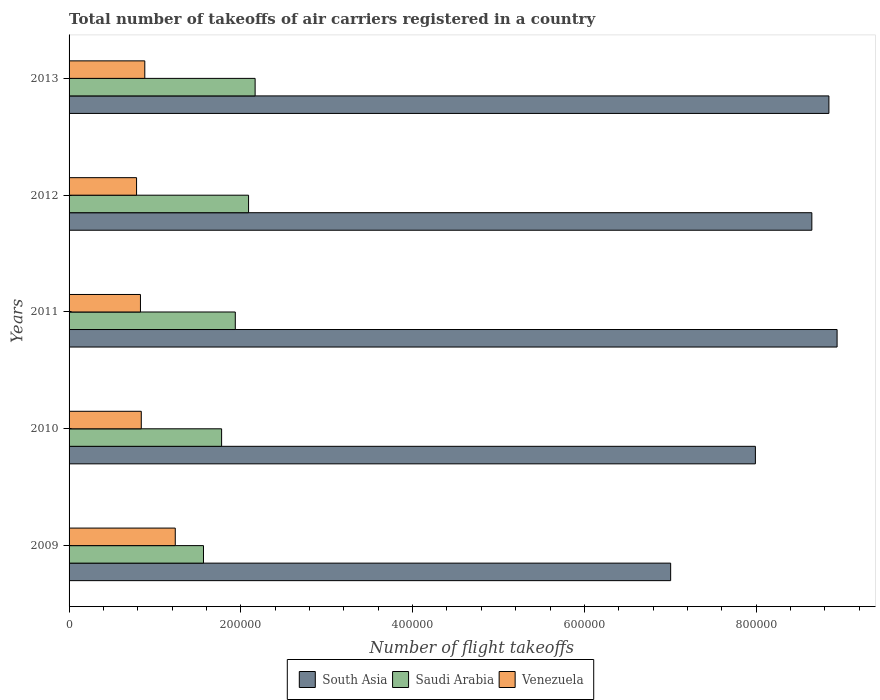How many groups of bars are there?
Your answer should be very brief. 5. How many bars are there on the 2nd tick from the bottom?
Keep it short and to the point. 3. What is the label of the 1st group of bars from the top?
Offer a very short reply. 2013. In how many cases, is the number of bars for a given year not equal to the number of legend labels?
Make the answer very short. 0. What is the total number of flight takeoffs in Venezuela in 2010?
Keep it short and to the point. 8.41e+04. Across all years, what is the maximum total number of flight takeoffs in Venezuela?
Your answer should be very brief. 1.24e+05. Across all years, what is the minimum total number of flight takeoffs in Saudi Arabia?
Provide a short and direct response. 1.56e+05. In which year was the total number of flight takeoffs in Venezuela minimum?
Offer a terse response. 2012. What is the total total number of flight takeoffs in Venezuela in the graph?
Make the answer very short. 4.58e+05. What is the difference between the total number of flight takeoffs in Saudi Arabia in 2009 and that in 2013?
Your answer should be compact. -6.01e+04. What is the difference between the total number of flight takeoffs in Venezuela in 2009 and the total number of flight takeoffs in South Asia in 2011?
Your response must be concise. -7.71e+05. What is the average total number of flight takeoffs in South Asia per year?
Give a very brief answer. 8.29e+05. In the year 2012, what is the difference between the total number of flight takeoffs in South Asia and total number of flight takeoffs in Venezuela?
Give a very brief answer. 7.86e+05. What is the ratio of the total number of flight takeoffs in South Asia in 2012 to that in 2013?
Your response must be concise. 0.98. Is the total number of flight takeoffs in South Asia in 2009 less than that in 2013?
Offer a very short reply. Yes. Is the difference between the total number of flight takeoffs in South Asia in 2010 and 2012 greater than the difference between the total number of flight takeoffs in Venezuela in 2010 and 2012?
Give a very brief answer. No. What is the difference between the highest and the second highest total number of flight takeoffs in Saudi Arabia?
Your answer should be very brief. 7630. What is the difference between the highest and the lowest total number of flight takeoffs in South Asia?
Your answer should be very brief. 1.94e+05. What does the 1st bar from the bottom in 2013 represents?
Provide a succinct answer. South Asia. Does the graph contain grids?
Offer a very short reply. No. What is the title of the graph?
Give a very brief answer. Total number of takeoffs of air carriers registered in a country. What is the label or title of the X-axis?
Offer a very short reply. Number of flight takeoffs. What is the label or title of the Y-axis?
Ensure brevity in your answer.  Years. What is the Number of flight takeoffs in South Asia in 2009?
Ensure brevity in your answer.  7.00e+05. What is the Number of flight takeoffs in Saudi Arabia in 2009?
Provide a succinct answer. 1.56e+05. What is the Number of flight takeoffs of Venezuela in 2009?
Offer a very short reply. 1.24e+05. What is the Number of flight takeoffs of South Asia in 2010?
Ensure brevity in your answer.  7.99e+05. What is the Number of flight takeoffs in Saudi Arabia in 2010?
Offer a very short reply. 1.78e+05. What is the Number of flight takeoffs in Venezuela in 2010?
Give a very brief answer. 8.41e+04. What is the Number of flight takeoffs of South Asia in 2011?
Make the answer very short. 8.94e+05. What is the Number of flight takeoffs in Saudi Arabia in 2011?
Provide a short and direct response. 1.94e+05. What is the Number of flight takeoffs of Venezuela in 2011?
Offer a very short reply. 8.31e+04. What is the Number of flight takeoffs in South Asia in 2012?
Keep it short and to the point. 8.65e+05. What is the Number of flight takeoffs in Saudi Arabia in 2012?
Your answer should be compact. 2.09e+05. What is the Number of flight takeoffs of Venezuela in 2012?
Your response must be concise. 7.86e+04. What is the Number of flight takeoffs of South Asia in 2013?
Your answer should be very brief. 8.85e+05. What is the Number of flight takeoffs in Saudi Arabia in 2013?
Make the answer very short. 2.17e+05. What is the Number of flight takeoffs in Venezuela in 2013?
Provide a short and direct response. 8.82e+04. Across all years, what is the maximum Number of flight takeoffs in South Asia?
Your answer should be compact. 8.94e+05. Across all years, what is the maximum Number of flight takeoffs in Saudi Arabia?
Offer a terse response. 2.17e+05. Across all years, what is the maximum Number of flight takeoffs in Venezuela?
Make the answer very short. 1.24e+05. Across all years, what is the minimum Number of flight takeoffs in South Asia?
Your response must be concise. 7.00e+05. Across all years, what is the minimum Number of flight takeoffs in Saudi Arabia?
Give a very brief answer. 1.56e+05. Across all years, what is the minimum Number of flight takeoffs in Venezuela?
Offer a terse response. 7.86e+04. What is the total Number of flight takeoffs of South Asia in the graph?
Provide a succinct answer. 4.14e+06. What is the total Number of flight takeoffs of Saudi Arabia in the graph?
Your answer should be very brief. 9.53e+05. What is the total Number of flight takeoffs of Venezuela in the graph?
Provide a succinct answer. 4.58e+05. What is the difference between the Number of flight takeoffs in South Asia in 2009 and that in 2010?
Your answer should be very brief. -9.86e+04. What is the difference between the Number of flight takeoffs of Saudi Arabia in 2009 and that in 2010?
Offer a terse response. -2.11e+04. What is the difference between the Number of flight takeoffs in Venezuela in 2009 and that in 2010?
Keep it short and to the point. 3.96e+04. What is the difference between the Number of flight takeoffs of South Asia in 2009 and that in 2011?
Keep it short and to the point. -1.94e+05. What is the difference between the Number of flight takeoffs of Saudi Arabia in 2009 and that in 2011?
Offer a terse response. -3.70e+04. What is the difference between the Number of flight takeoffs in Venezuela in 2009 and that in 2011?
Provide a succinct answer. 4.05e+04. What is the difference between the Number of flight takeoffs in South Asia in 2009 and that in 2012?
Give a very brief answer. -1.64e+05. What is the difference between the Number of flight takeoffs in Saudi Arabia in 2009 and that in 2012?
Offer a terse response. -5.25e+04. What is the difference between the Number of flight takeoffs in Venezuela in 2009 and that in 2012?
Your answer should be very brief. 4.51e+04. What is the difference between the Number of flight takeoffs in South Asia in 2009 and that in 2013?
Your answer should be very brief. -1.84e+05. What is the difference between the Number of flight takeoffs of Saudi Arabia in 2009 and that in 2013?
Offer a very short reply. -6.01e+04. What is the difference between the Number of flight takeoffs of Venezuela in 2009 and that in 2013?
Your answer should be very brief. 3.55e+04. What is the difference between the Number of flight takeoffs in South Asia in 2010 and that in 2011?
Your answer should be compact. -9.51e+04. What is the difference between the Number of flight takeoffs of Saudi Arabia in 2010 and that in 2011?
Provide a short and direct response. -1.59e+04. What is the difference between the Number of flight takeoffs in Venezuela in 2010 and that in 2011?
Your answer should be very brief. 959. What is the difference between the Number of flight takeoffs in South Asia in 2010 and that in 2012?
Your answer should be very brief. -6.57e+04. What is the difference between the Number of flight takeoffs of Saudi Arabia in 2010 and that in 2012?
Give a very brief answer. -3.14e+04. What is the difference between the Number of flight takeoffs of Venezuela in 2010 and that in 2012?
Offer a very short reply. 5481.84. What is the difference between the Number of flight takeoffs in South Asia in 2010 and that in 2013?
Provide a short and direct response. -8.56e+04. What is the difference between the Number of flight takeoffs of Saudi Arabia in 2010 and that in 2013?
Offer a very short reply. -3.90e+04. What is the difference between the Number of flight takeoffs in Venezuela in 2010 and that in 2013?
Your answer should be compact. -4103.8. What is the difference between the Number of flight takeoffs in South Asia in 2011 and that in 2012?
Make the answer very short. 2.94e+04. What is the difference between the Number of flight takeoffs of Saudi Arabia in 2011 and that in 2012?
Ensure brevity in your answer.  -1.54e+04. What is the difference between the Number of flight takeoffs in Venezuela in 2011 and that in 2012?
Provide a short and direct response. 4522.84. What is the difference between the Number of flight takeoffs of South Asia in 2011 and that in 2013?
Provide a succinct answer. 9522.73. What is the difference between the Number of flight takeoffs of Saudi Arabia in 2011 and that in 2013?
Provide a succinct answer. -2.31e+04. What is the difference between the Number of flight takeoffs in Venezuela in 2011 and that in 2013?
Provide a short and direct response. -5062.8. What is the difference between the Number of flight takeoffs in South Asia in 2012 and that in 2013?
Ensure brevity in your answer.  -1.99e+04. What is the difference between the Number of flight takeoffs of Saudi Arabia in 2012 and that in 2013?
Provide a succinct answer. -7630. What is the difference between the Number of flight takeoffs in Venezuela in 2012 and that in 2013?
Provide a short and direct response. -9585.64. What is the difference between the Number of flight takeoffs of South Asia in 2009 and the Number of flight takeoffs of Saudi Arabia in 2010?
Keep it short and to the point. 5.23e+05. What is the difference between the Number of flight takeoffs in South Asia in 2009 and the Number of flight takeoffs in Venezuela in 2010?
Your response must be concise. 6.16e+05. What is the difference between the Number of flight takeoffs of Saudi Arabia in 2009 and the Number of flight takeoffs of Venezuela in 2010?
Offer a terse response. 7.24e+04. What is the difference between the Number of flight takeoffs in South Asia in 2009 and the Number of flight takeoffs in Saudi Arabia in 2011?
Give a very brief answer. 5.07e+05. What is the difference between the Number of flight takeoffs of South Asia in 2009 and the Number of flight takeoffs of Venezuela in 2011?
Your answer should be compact. 6.17e+05. What is the difference between the Number of flight takeoffs of Saudi Arabia in 2009 and the Number of flight takeoffs of Venezuela in 2011?
Offer a very short reply. 7.34e+04. What is the difference between the Number of flight takeoffs in South Asia in 2009 and the Number of flight takeoffs in Saudi Arabia in 2012?
Your answer should be very brief. 4.91e+05. What is the difference between the Number of flight takeoffs in South Asia in 2009 and the Number of flight takeoffs in Venezuela in 2012?
Give a very brief answer. 6.22e+05. What is the difference between the Number of flight takeoffs of Saudi Arabia in 2009 and the Number of flight takeoffs of Venezuela in 2012?
Offer a terse response. 7.79e+04. What is the difference between the Number of flight takeoffs of South Asia in 2009 and the Number of flight takeoffs of Saudi Arabia in 2013?
Ensure brevity in your answer.  4.84e+05. What is the difference between the Number of flight takeoffs in South Asia in 2009 and the Number of flight takeoffs in Venezuela in 2013?
Provide a succinct answer. 6.12e+05. What is the difference between the Number of flight takeoffs of Saudi Arabia in 2009 and the Number of flight takeoffs of Venezuela in 2013?
Your response must be concise. 6.83e+04. What is the difference between the Number of flight takeoffs in South Asia in 2010 and the Number of flight takeoffs in Saudi Arabia in 2011?
Your answer should be very brief. 6.06e+05. What is the difference between the Number of flight takeoffs of South Asia in 2010 and the Number of flight takeoffs of Venezuela in 2011?
Keep it short and to the point. 7.16e+05. What is the difference between the Number of flight takeoffs of Saudi Arabia in 2010 and the Number of flight takeoffs of Venezuela in 2011?
Ensure brevity in your answer.  9.45e+04. What is the difference between the Number of flight takeoffs in South Asia in 2010 and the Number of flight takeoffs in Saudi Arabia in 2012?
Provide a short and direct response. 5.90e+05. What is the difference between the Number of flight takeoffs of South Asia in 2010 and the Number of flight takeoffs of Venezuela in 2012?
Provide a succinct answer. 7.20e+05. What is the difference between the Number of flight takeoffs of Saudi Arabia in 2010 and the Number of flight takeoffs of Venezuela in 2012?
Ensure brevity in your answer.  9.90e+04. What is the difference between the Number of flight takeoffs in South Asia in 2010 and the Number of flight takeoffs in Saudi Arabia in 2013?
Offer a very short reply. 5.82e+05. What is the difference between the Number of flight takeoffs in South Asia in 2010 and the Number of flight takeoffs in Venezuela in 2013?
Provide a short and direct response. 7.11e+05. What is the difference between the Number of flight takeoffs in Saudi Arabia in 2010 and the Number of flight takeoffs in Venezuela in 2013?
Provide a succinct answer. 8.94e+04. What is the difference between the Number of flight takeoffs in South Asia in 2011 and the Number of flight takeoffs in Saudi Arabia in 2012?
Provide a succinct answer. 6.85e+05. What is the difference between the Number of flight takeoffs in South Asia in 2011 and the Number of flight takeoffs in Venezuela in 2012?
Offer a terse response. 8.16e+05. What is the difference between the Number of flight takeoffs of Saudi Arabia in 2011 and the Number of flight takeoffs of Venezuela in 2012?
Provide a succinct answer. 1.15e+05. What is the difference between the Number of flight takeoffs of South Asia in 2011 and the Number of flight takeoffs of Saudi Arabia in 2013?
Offer a terse response. 6.78e+05. What is the difference between the Number of flight takeoffs in South Asia in 2011 and the Number of flight takeoffs in Venezuela in 2013?
Make the answer very short. 8.06e+05. What is the difference between the Number of flight takeoffs in Saudi Arabia in 2011 and the Number of flight takeoffs in Venezuela in 2013?
Make the answer very short. 1.05e+05. What is the difference between the Number of flight takeoffs of South Asia in 2012 and the Number of flight takeoffs of Saudi Arabia in 2013?
Provide a succinct answer. 6.48e+05. What is the difference between the Number of flight takeoffs in South Asia in 2012 and the Number of flight takeoffs in Venezuela in 2013?
Your answer should be very brief. 7.77e+05. What is the difference between the Number of flight takeoffs of Saudi Arabia in 2012 and the Number of flight takeoffs of Venezuela in 2013?
Ensure brevity in your answer.  1.21e+05. What is the average Number of flight takeoffs in South Asia per year?
Give a very brief answer. 8.29e+05. What is the average Number of flight takeoffs of Saudi Arabia per year?
Keep it short and to the point. 1.91e+05. What is the average Number of flight takeoffs of Venezuela per year?
Give a very brief answer. 9.15e+04. In the year 2009, what is the difference between the Number of flight takeoffs of South Asia and Number of flight takeoffs of Saudi Arabia?
Provide a short and direct response. 5.44e+05. In the year 2009, what is the difference between the Number of flight takeoffs in South Asia and Number of flight takeoffs in Venezuela?
Ensure brevity in your answer.  5.77e+05. In the year 2009, what is the difference between the Number of flight takeoffs of Saudi Arabia and Number of flight takeoffs of Venezuela?
Offer a very short reply. 3.29e+04. In the year 2010, what is the difference between the Number of flight takeoffs in South Asia and Number of flight takeoffs in Saudi Arabia?
Keep it short and to the point. 6.21e+05. In the year 2010, what is the difference between the Number of flight takeoffs of South Asia and Number of flight takeoffs of Venezuela?
Ensure brevity in your answer.  7.15e+05. In the year 2010, what is the difference between the Number of flight takeoffs in Saudi Arabia and Number of flight takeoffs in Venezuela?
Keep it short and to the point. 9.35e+04. In the year 2011, what is the difference between the Number of flight takeoffs of South Asia and Number of flight takeoffs of Saudi Arabia?
Your answer should be very brief. 7.01e+05. In the year 2011, what is the difference between the Number of flight takeoffs of South Asia and Number of flight takeoffs of Venezuela?
Keep it short and to the point. 8.11e+05. In the year 2011, what is the difference between the Number of flight takeoffs of Saudi Arabia and Number of flight takeoffs of Venezuela?
Provide a succinct answer. 1.10e+05. In the year 2012, what is the difference between the Number of flight takeoffs in South Asia and Number of flight takeoffs in Saudi Arabia?
Keep it short and to the point. 6.56e+05. In the year 2012, what is the difference between the Number of flight takeoffs in South Asia and Number of flight takeoffs in Venezuela?
Make the answer very short. 7.86e+05. In the year 2012, what is the difference between the Number of flight takeoffs in Saudi Arabia and Number of flight takeoffs in Venezuela?
Your response must be concise. 1.30e+05. In the year 2013, what is the difference between the Number of flight takeoffs in South Asia and Number of flight takeoffs in Saudi Arabia?
Provide a short and direct response. 6.68e+05. In the year 2013, what is the difference between the Number of flight takeoffs of South Asia and Number of flight takeoffs of Venezuela?
Offer a terse response. 7.97e+05. In the year 2013, what is the difference between the Number of flight takeoffs of Saudi Arabia and Number of flight takeoffs of Venezuela?
Offer a terse response. 1.28e+05. What is the ratio of the Number of flight takeoffs in South Asia in 2009 to that in 2010?
Offer a very short reply. 0.88. What is the ratio of the Number of flight takeoffs in Saudi Arabia in 2009 to that in 2010?
Your answer should be compact. 0.88. What is the ratio of the Number of flight takeoffs in Venezuela in 2009 to that in 2010?
Make the answer very short. 1.47. What is the ratio of the Number of flight takeoffs in South Asia in 2009 to that in 2011?
Your answer should be compact. 0.78. What is the ratio of the Number of flight takeoffs in Saudi Arabia in 2009 to that in 2011?
Your response must be concise. 0.81. What is the ratio of the Number of flight takeoffs in Venezuela in 2009 to that in 2011?
Your answer should be very brief. 1.49. What is the ratio of the Number of flight takeoffs of South Asia in 2009 to that in 2012?
Make the answer very short. 0.81. What is the ratio of the Number of flight takeoffs of Saudi Arabia in 2009 to that in 2012?
Your answer should be compact. 0.75. What is the ratio of the Number of flight takeoffs in Venezuela in 2009 to that in 2012?
Offer a terse response. 1.57. What is the ratio of the Number of flight takeoffs in South Asia in 2009 to that in 2013?
Provide a short and direct response. 0.79. What is the ratio of the Number of flight takeoffs of Saudi Arabia in 2009 to that in 2013?
Keep it short and to the point. 0.72. What is the ratio of the Number of flight takeoffs of Venezuela in 2009 to that in 2013?
Make the answer very short. 1.4. What is the ratio of the Number of flight takeoffs in South Asia in 2010 to that in 2011?
Give a very brief answer. 0.89. What is the ratio of the Number of flight takeoffs in Saudi Arabia in 2010 to that in 2011?
Ensure brevity in your answer.  0.92. What is the ratio of the Number of flight takeoffs in Venezuela in 2010 to that in 2011?
Provide a short and direct response. 1.01. What is the ratio of the Number of flight takeoffs of South Asia in 2010 to that in 2012?
Give a very brief answer. 0.92. What is the ratio of the Number of flight takeoffs of Saudi Arabia in 2010 to that in 2012?
Provide a short and direct response. 0.85. What is the ratio of the Number of flight takeoffs in Venezuela in 2010 to that in 2012?
Your answer should be very brief. 1.07. What is the ratio of the Number of flight takeoffs of South Asia in 2010 to that in 2013?
Ensure brevity in your answer.  0.9. What is the ratio of the Number of flight takeoffs in Saudi Arabia in 2010 to that in 2013?
Ensure brevity in your answer.  0.82. What is the ratio of the Number of flight takeoffs of Venezuela in 2010 to that in 2013?
Ensure brevity in your answer.  0.95. What is the ratio of the Number of flight takeoffs in South Asia in 2011 to that in 2012?
Provide a short and direct response. 1.03. What is the ratio of the Number of flight takeoffs of Saudi Arabia in 2011 to that in 2012?
Your answer should be very brief. 0.93. What is the ratio of the Number of flight takeoffs in Venezuela in 2011 to that in 2012?
Make the answer very short. 1.06. What is the ratio of the Number of flight takeoffs in South Asia in 2011 to that in 2013?
Ensure brevity in your answer.  1.01. What is the ratio of the Number of flight takeoffs in Saudi Arabia in 2011 to that in 2013?
Your response must be concise. 0.89. What is the ratio of the Number of flight takeoffs of Venezuela in 2011 to that in 2013?
Keep it short and to the point. 0.94. What is the ratio of the Number of flight takeoffs in South Asia in 2012 to that in 2013?
Your response must be concise. 0.98. What is the ratio of the Number of flight takeoffs of Saudi Arabia in 2012 to that in 2013?
Offer a very short reply. 0.96. What is the ratio of the Number of flight takeoffs of Venezuela in 2012 to that in 2013?
Give a very brief answer. 0.89. What is the difference between the highest and the second highest Number of flight takeoffs in South Asia?
Your answer should be very brief. 9522.73. What is the difference between the highest and the second highest Number of flight takeoffs in Saudi Arabia?
Provide a short and direct response. 7630. What is the difference between the highest and the second highest Number of flight takeoffs in Venezuela?
Keep it short and to the point. 3.55e+04. What is the difference between the highest and the lowest Number of flight takeoffs in South Asia?
Offer a very short reply. 1.94e+05. What is the difference between the highest and the lowest Number of flight takeoffs in Saudi Arabia?
Provide a short and direct response. 6.01e+04. What is the difference between the highest and the lowest Number of flight takeoffs in Venezuela?
Your answer should be very brief. 4.51e+04. 